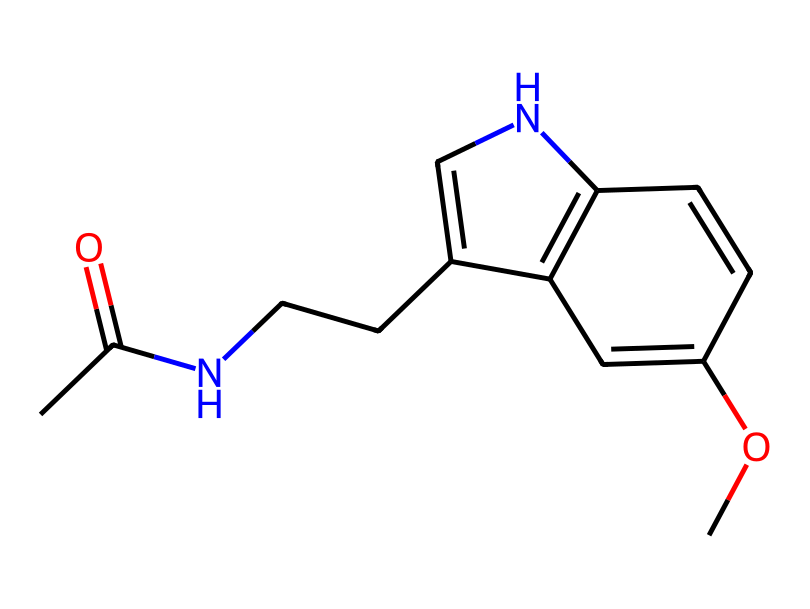What is the chemical name of this compound? The SMILES representation corresponds to melatonin, which is a hormone that regulates sleep-wake cycles.
Answer: melatonin How many nitrogen atoms are present in the chemical structure? By analyzing the SMILES representation, there are two nitrogen atoms in the structure.
Answer: 2 What type of functional group is present in this molecule? The presence of the carbonyl group (C=O) indicates that there is an amide functional group in the structure.
Answer: amide Which atom in the structure contributes to its water solubility? The presence of the hydroxyl group (-OH) attached to the aromatic ring contributes to its water solubility because hydroxyl groups are polar.
Answer: hydroxyl What is the main biological function of this hormone? Melatonin primarily regulates sleep-wake cycles in the body, influencing circadian rhythms.
Answer: regulates sleep-wake cycles What does the presence of the indole ring suggest about this hormone? The indole ring, a bicyclic structure that includes a nitrogen atom, suggests that melatonin is derived from tryptophan, an essential amino acid.
Answer: derived from tryptophan 